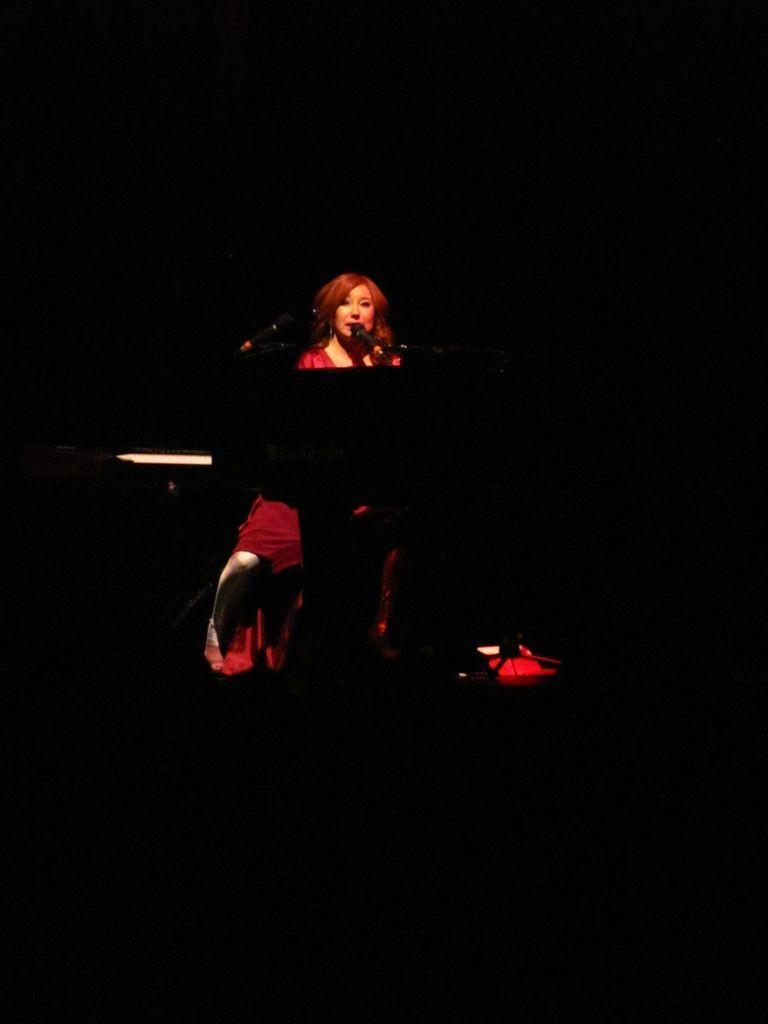Please provide a concise description of this image. Here in this picture we can see a woman sitting over a place and singing a song in the microphone present in front of her and we can also see a stand present in front of her and we can see a light also present. 